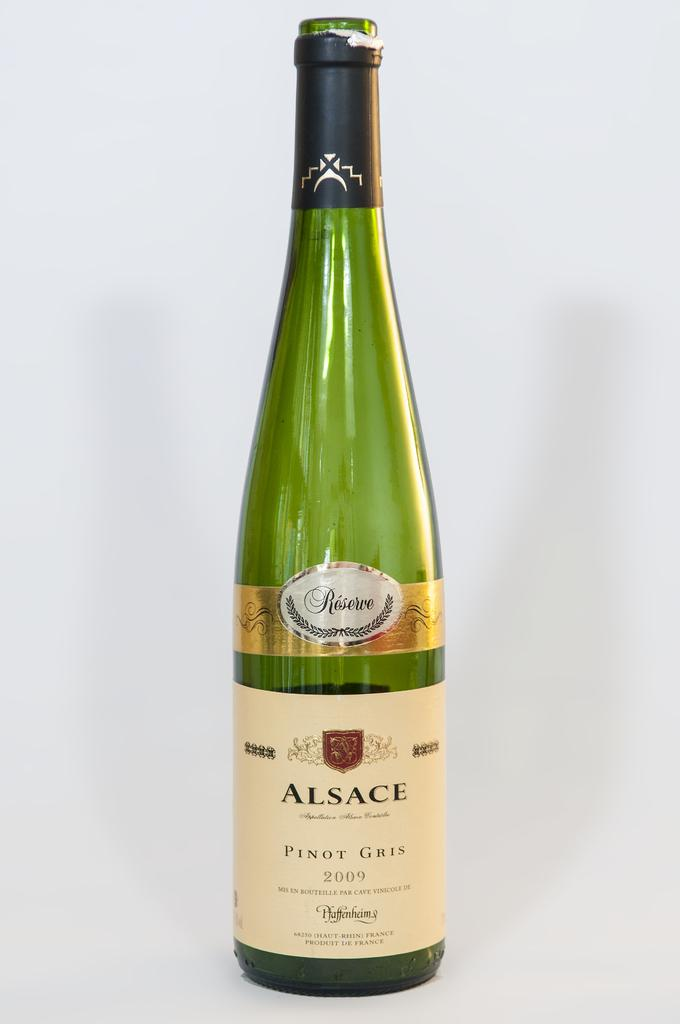<image>
Describe the image concisely. A bottle of pinot gris from 2009 is opened with the cork gone. 